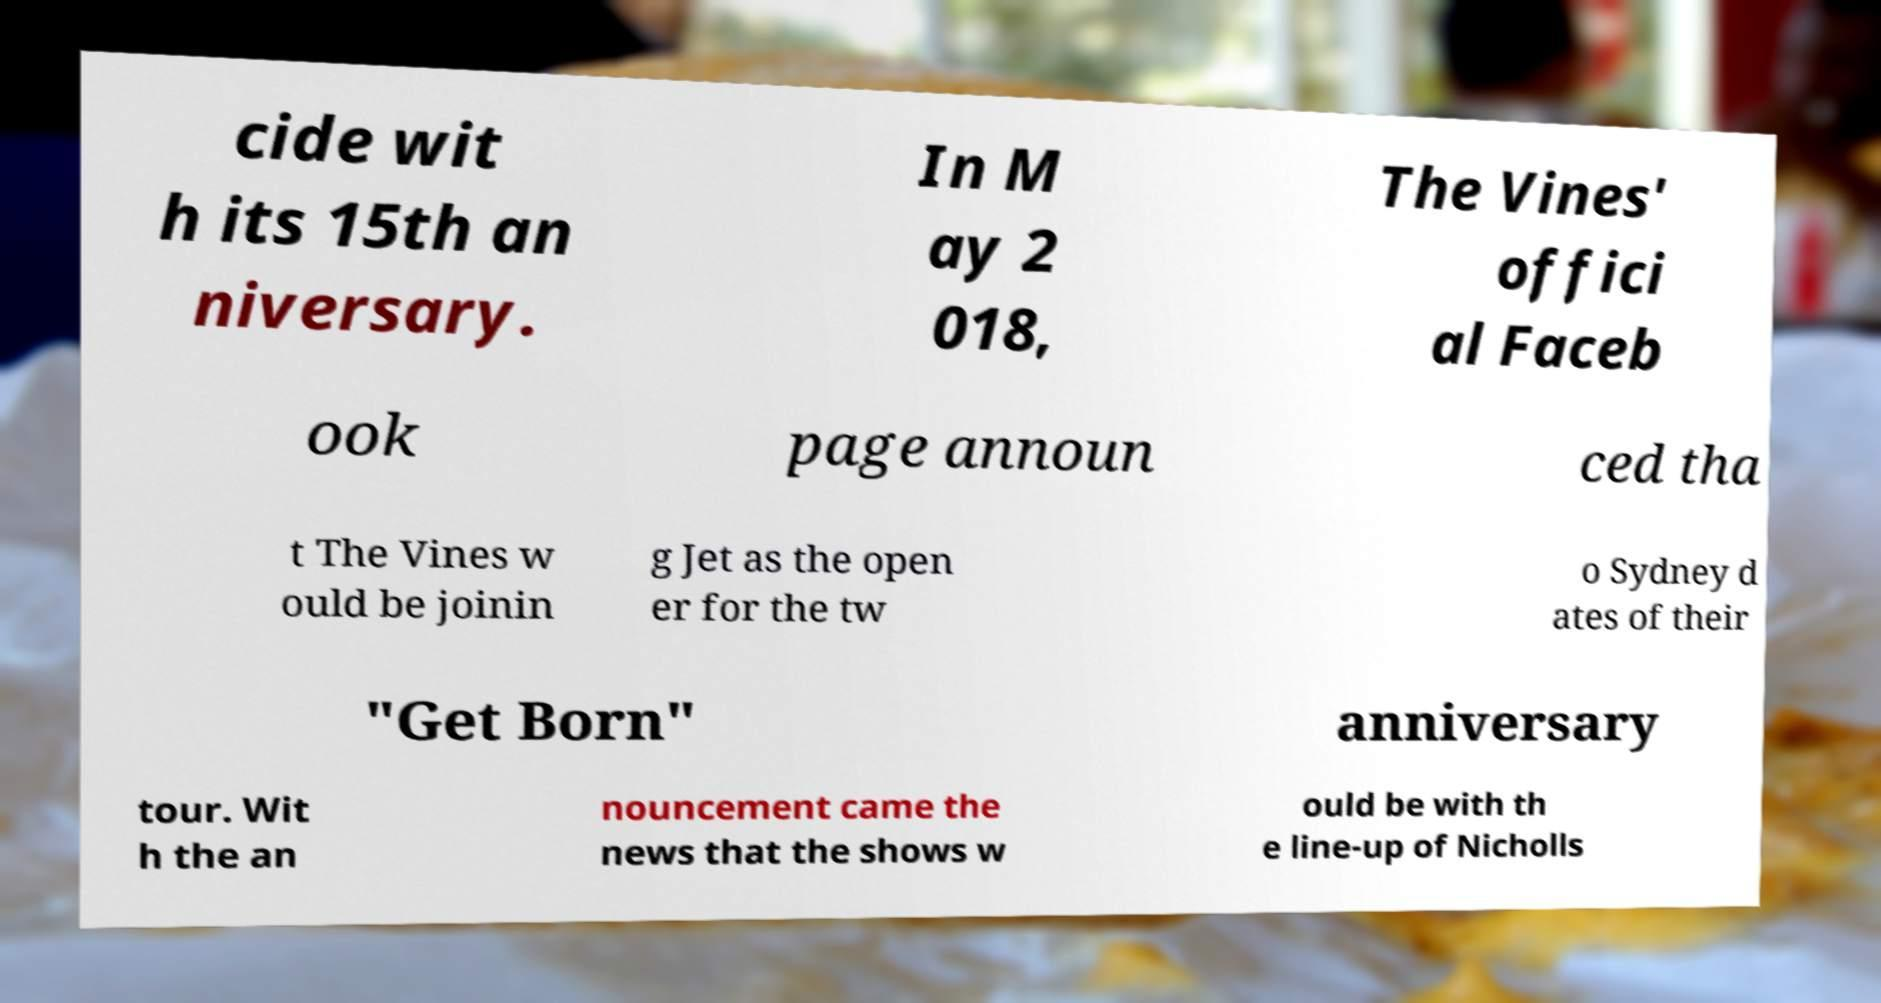Could you assist in decoding the text presented in this image and type it out clearly? cide wit h its 15th an niversary. In M ay 2 018, The Vines' offici al Faceb ook page announ ced tha t The Vines w ould be joinin g Jet as the open er for the tw o Sydney d ates of their "Get Born" anniversary tour. Wit h the an nouncement came the news that the shows w ould be with th e line-up of Nicholls 